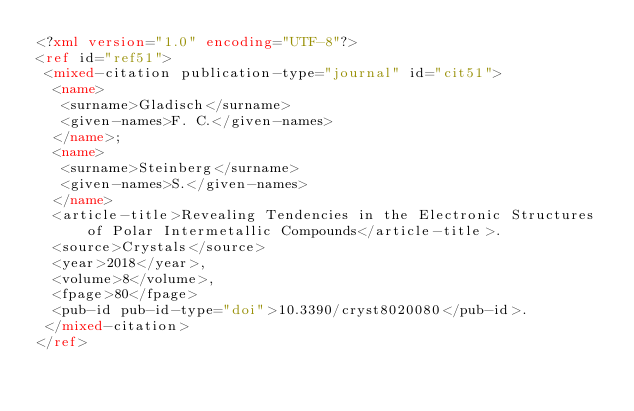Convert code to text. <code><loc_0><loc_0><loc_500><loc_500><_XML_><?xml version="1.0" encoding="UTF-8"?>
<ref id="ref51">
 <mixed-citation publication-type="journal" id="cit51">
  <name>
   <surname>Gladisch</surname>
   <given-names>F. C.</given-names>
  </name>; 
  <name>
   <surname>Steinberg</surname>
   <given-names>S.</given-names>
  </name>
  <article-title>Revealing Tendencies in the Electronic Structures of Polar Intermetallic Compounds</article-title>. 
  <source>Crystals</source>
  <year>2018</year>, 
  <volume>8</volume>, 
  <fpage>80</fpage>
  <pub-id pub-id-type="doi">10.3390/cryst8020080</pub-id>.
 </mixed-citation>
</ref>
</code> 